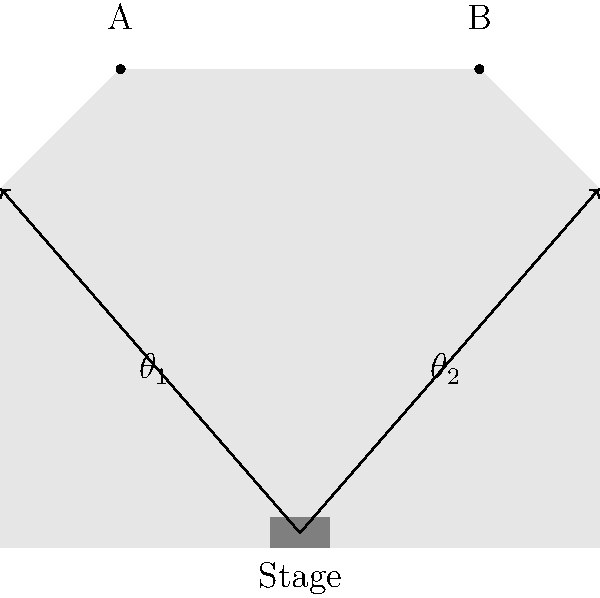At the BTS concert, you and your friend are sitting in different sections of the stadium. You're at point A, and your friend is at point B. The stage is located at the center of the stadium floor. If the width of the stage is 10 meters and the height of the stage is 5 meters, what is the difference between your viewing angles ($\theta_1$ and $\theta_2$) in degrees? Let's solve this step-by-step:

1) First, we need to calculate the viewing angles $\theta_1$ and $\theta_2$.

2) For $\theta_1$ (your angle):
   - The opposite side is the height of the stage = 5 meters
   - The adjacent side is the horizontal distance from A to the center of the stage
   - This distance is half the width of the stadium minus half the width of the stage
   - Let's assume the stadium is 100 meters wide: (100/2) - (10/2) = 45 meters
   
3) We can calculate $\theta_1$ using the arctangent function:
   $\theta_1 = \arctan(\frac{5}{45}) \approx 6.34°$

4) For $\theta_2$ (your friend's angle):
   - The opposite and adjacent sides are the same as for $\theta_1$
   
5) Therefore, $\theta_2 = \theta_1 \approx 6.34°$

6) The difference between the angles is:
   $|\theta_2 - \theta_1| = |6.34° - 6.34°| = 0°$

Thus, there is no difference between your viewing angles.
Answer: $0°$ 